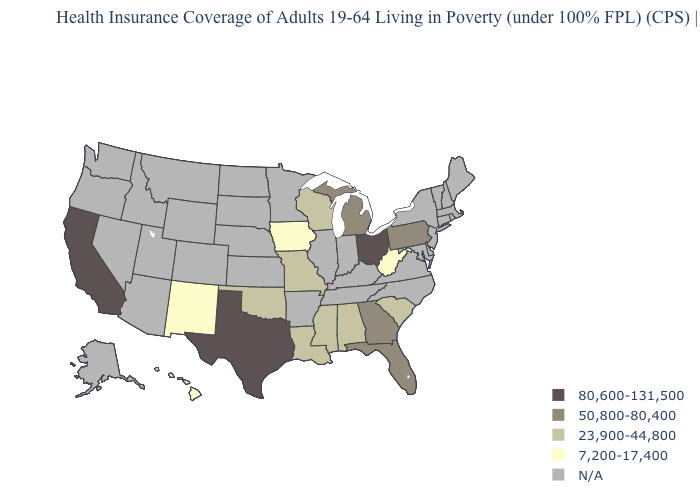What is the lowest value in the USA?
Concise answer only. 7,200-17,400. Which states hav the highest value in the South?
Answer briefly. Texas. What is the value of Missouri?
Answer briefly. 23,900-44,800. Which states have the highest value in the USA?
Keep it brief. California, Ohio, Texas. What is the value of Nebraska?
Short answer required. N/A. Name the states that have a value in the range 7,200-17,400?
Short answer required. Hawaii, Iowa, New Mexico, West Virginia. What is the lowest value in the USA?
Answer briefly. 7,200-17,400. What is the highest value in states that border Alabama?
Keep it brief. 50,800-80,400. What is the value of Maine?
Concise answer only. N/A. Does the first symbol in the legend represent the smallest category?
Be succinct. No. What is the value of Tennessee?
Concise answer only. N/A. What is the value of Delaware?
Keep it brief. N/A. Name the states that have a value in the range N/A?
Be succinct. Alaska, Arizona, Arkansas, Colorado, Connecticut, Delaware, Idaho, Illinois, Indiana, Kansas, Kentucky, Maine, Maryland, Massachusetts, Minnesota, Montana, Nebraska, Nevada, New Hampshire, New Jersey, New York, North Carolina, North Dakota, Oregon, Rhode Island, South Dakota, Tennessee, Utah, Vermont, Virginia, Washington, Wyoming. Name the states that have a value in the range N/A?
Answer briefly. Alaska, Arizona, Arkansas, Colorado, Connecticut, Delaware, Idaho, Illinois, Indiana, Kansas, Kentucky, Maine, Maryland, Massachusetts, Minnesota, Montana, Nebraska, Nevada, New Hampshire, New Jersey, New York, North Carolina, North Dakota, Oregon, Rhode Island, South Dakota, Tennessee, Utah, Vermont, Virginia, Washington, Wyoming. What is the lowest value in the USA?
Give a very brief answer. 7,200-17,400. 